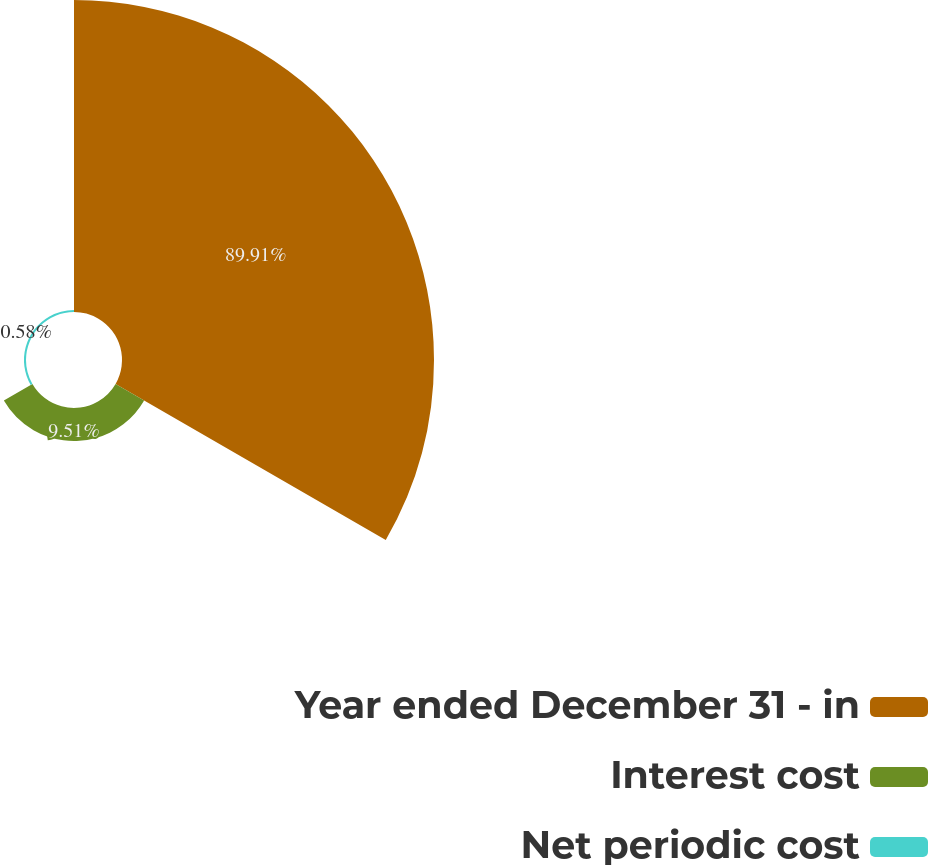<chart> <loc_0><loc_0><loc_500><loc_500><pie_chart><fcel>Year ended December 31 - in<fcel>Interest cost<fcel>Net periodic cost<nl><fcel>89.9%<fcel>9.51%<fcel>0.58%<nl></chart> 